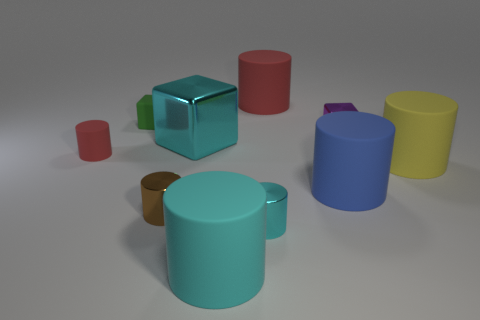How many objects are there in total? There are a total of seven objects visible in the image.  Can you tell me the colors of the objects starting from the largest? Certainly! Starting from the largest object, the colors are teal, dark blue, yellow, purple, green, red, and brown. 